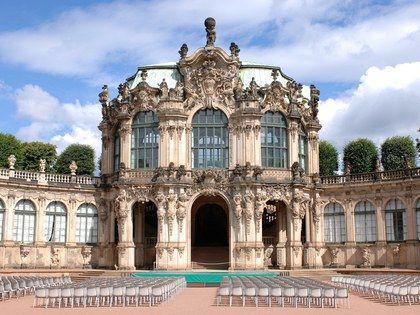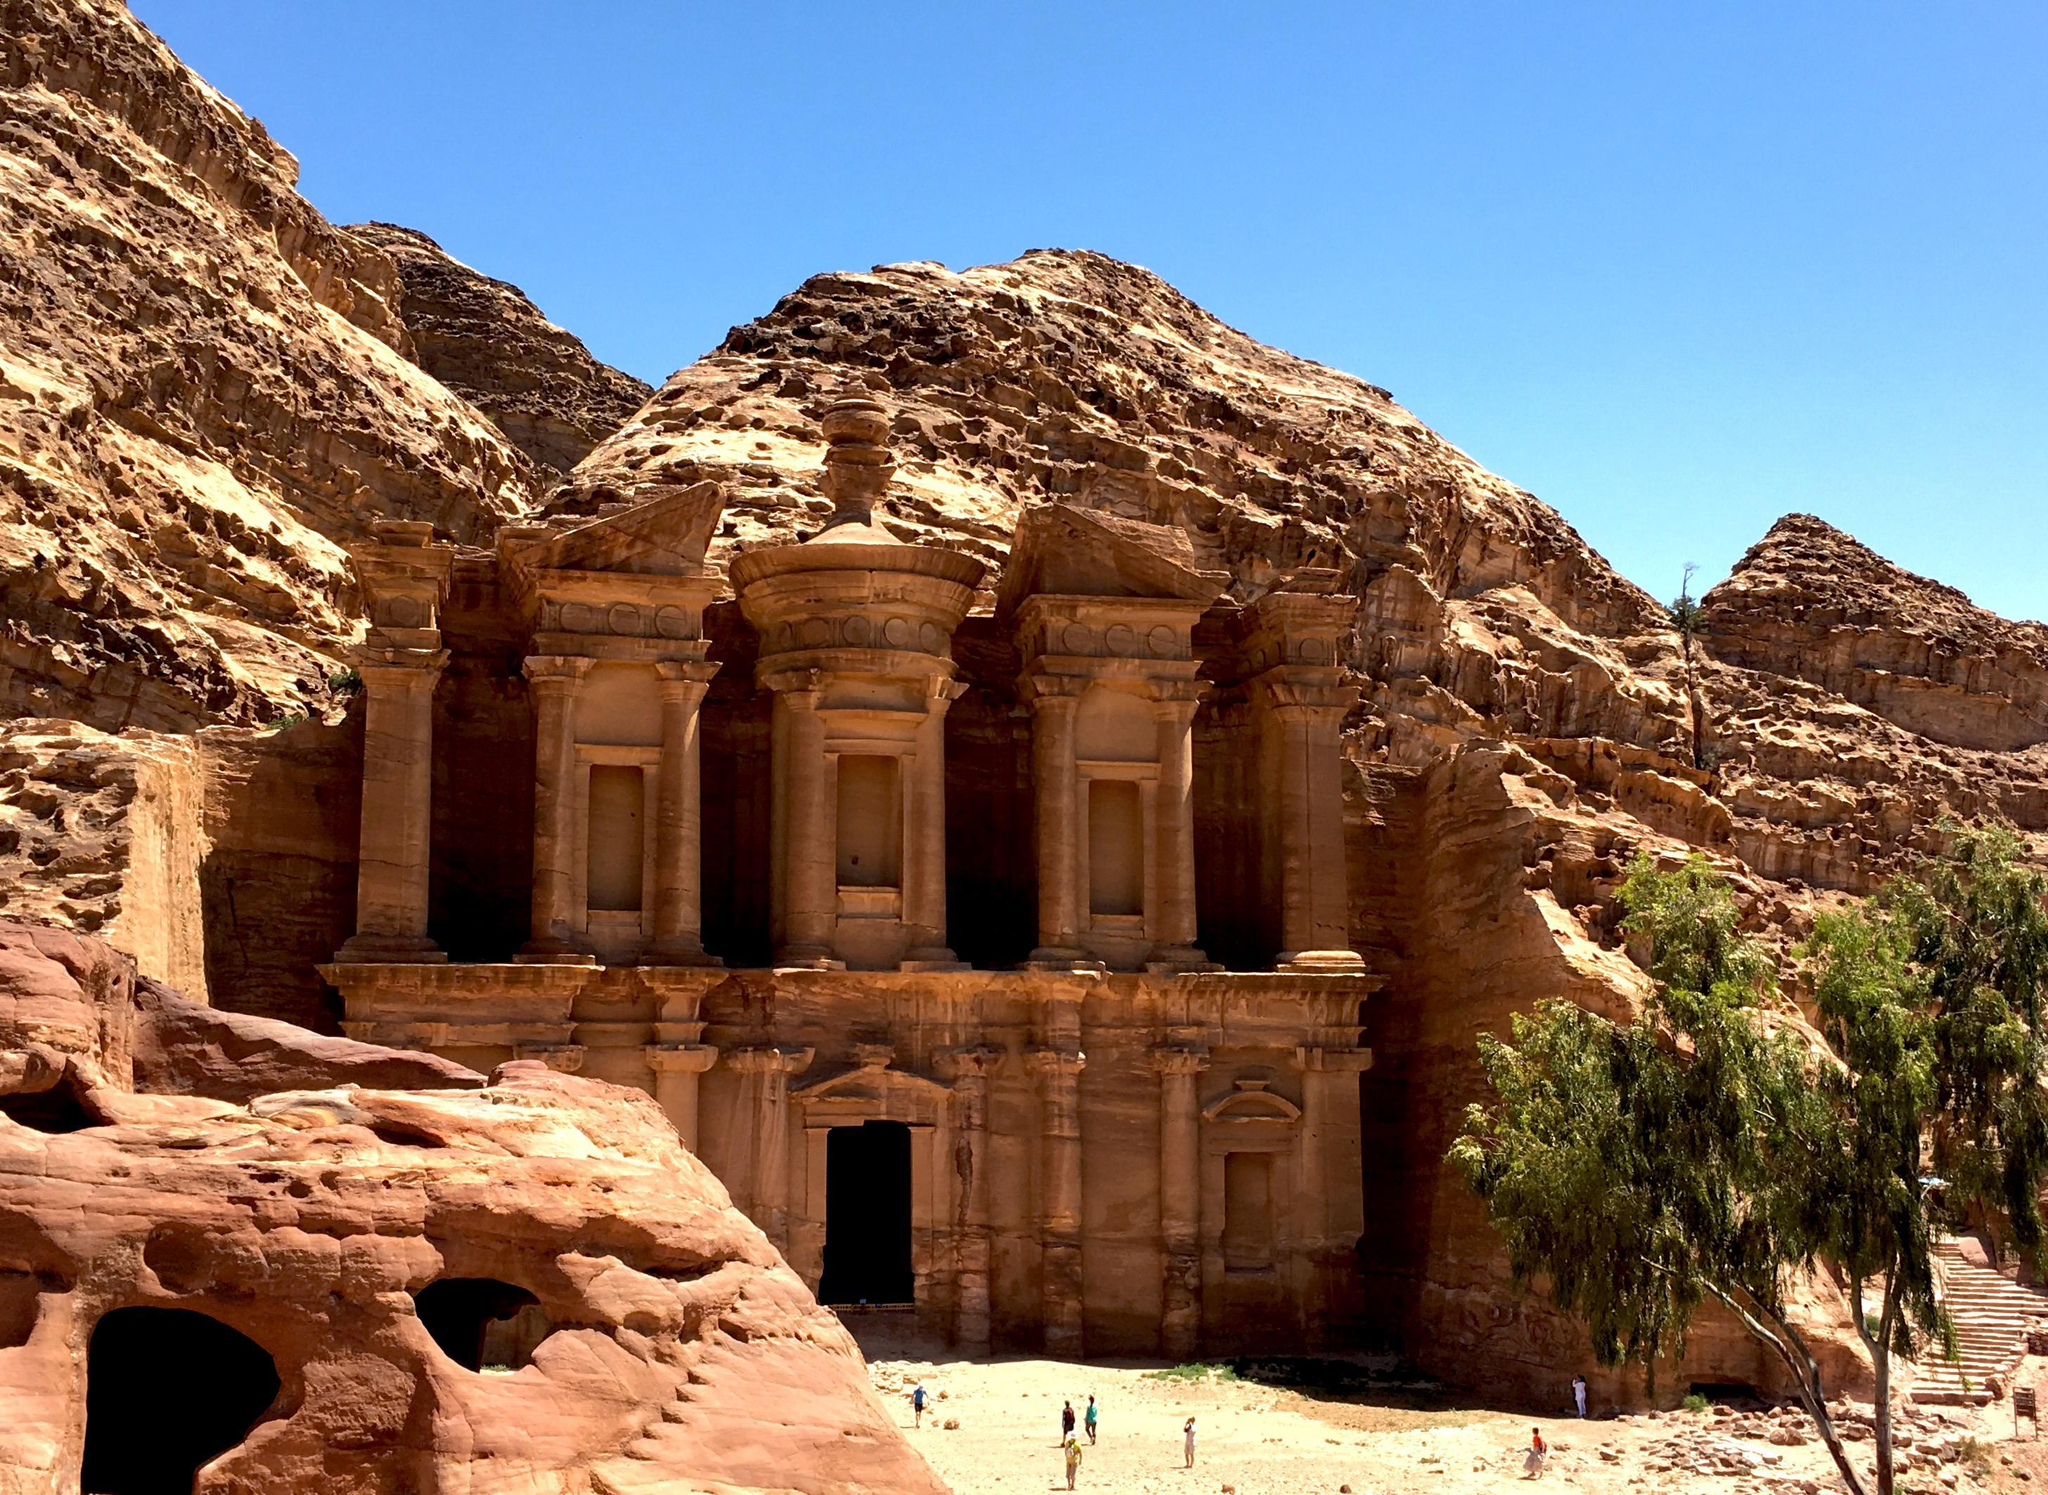The first image is the image on the left, the second image is the image on the right. Analyze the images presented: Is the assertion "The left and right image contains no less than four crosses." valid? Answer yes or no. No. The first image is the image on the left, the second image is the image on the right. Considering the images on both sides, is "The right image shows a beige building with a cone-shaped roof topped with a cross above a cylindrical tower." valid? Answer yes or no. No. 